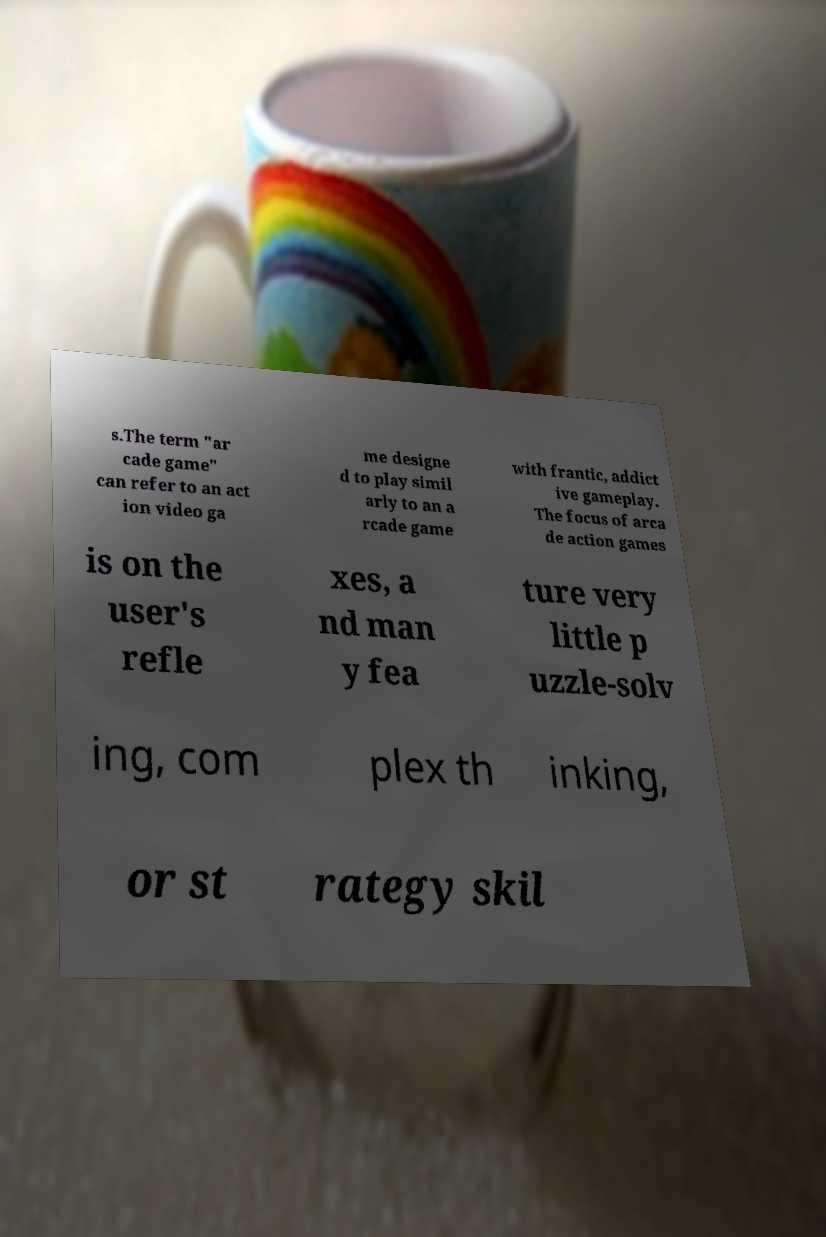Please identify and transcribe the text found in this image. s.The term "ar cade game" can refer to an act ion video ga me designe d to play simil arly to an a rcade game with frantic, addict ive gameplay. The focus of arca de action games is on the user's refle xes, a nd man y fea ture very little p uzzle-solv ing, com plex th inking, or st rategy skil 